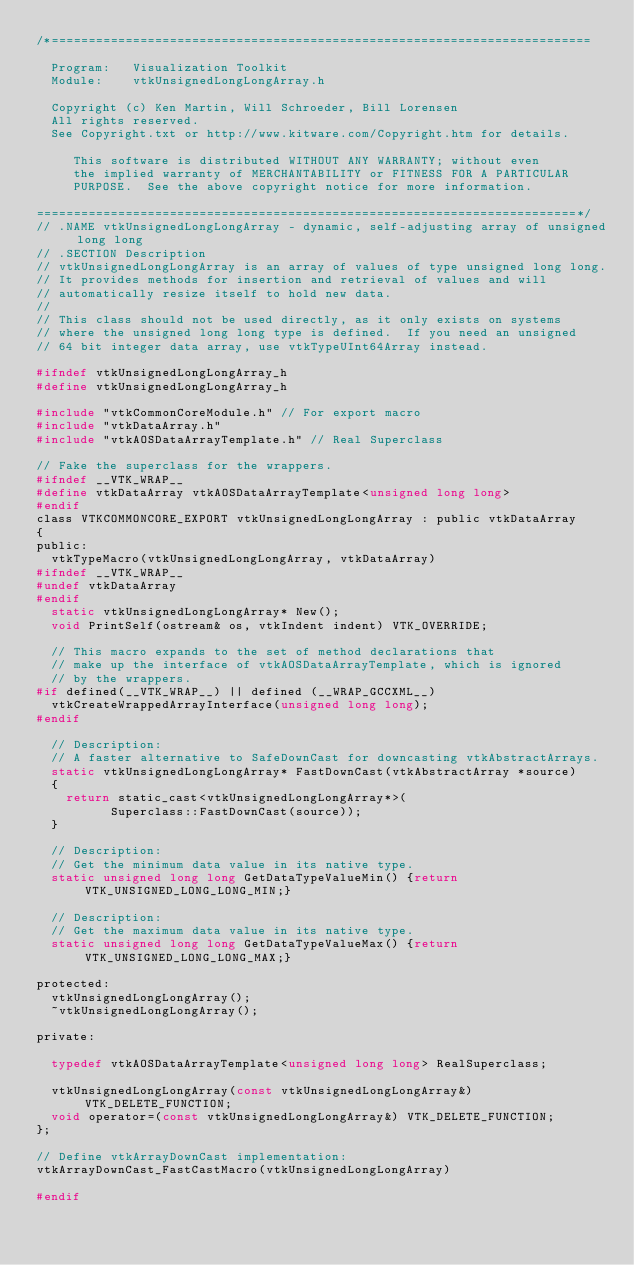Convert code to text. <code><loc_0><loc_0><loc_500><loc_500><_C_>/*=========================================================================

  Program:   Visualization Toolkit
  Module:    vtkUnsignedLongLongArray.h

  Copyright (c) Ken Martin, Will Schroeder, Bill Lorensen
  All rights reserved.
  See Copyright.txt or http://www.kitware.com/Copyright.htm for details.

     This software is distributed WITHOUT ANY WARRANTY; without even
     the implied warranty of MERCHANTABILITY or FITNESS FOR A PARTICULAR
     PURPOSE.  See the above copyright notice for more information.

=========================================================================*/
// .NAME vtkUnsignedLongLongArray - dynamic, self-adjusting array of unsigned long long
// .SECTION Description
// vtkUnsignedLongLongArray is an array of values of type unsigned long long.
// It provides methods for insertion and retrieval of values and will
// automatically resize itself to hold new data.
//
// This class should not be used directly, as it only exists on systems
// where the unsigned long long type is defined.  If you need an unsigned
// 64 bit integer data array, use vtkTypeUInt64Array instead.

#ifndef vtkUnsignedLongLongArray_h
#define vtkUnsignedLongLongArray_h

#include "vtkCommonCoreModule.h" // For export macro
#include "vtkDataArray.h"
#include "vtkAOSDataArrayTemplate.h" // Real Superclass

// Fake the superclass for the wrappers.
#ifndef __VTK_WRAP__
#define vtkDataArray vtkAOSDataArrayTemplate<unsigned long long>
#endif
class VTKCOMMONCORE_EXPORT vtkUnsignedLongLongArray : public vtkDataArray
{
public:
  vtkTypeMacro(vtkUnsignedLongLongArray, vtkDataArray)
#ifndef __VTK_WRAP__
#undef vtkDataArray
#endif
  static vtkUnsignedLongLongArray* New();
  void PrintSelf(ostream& os, vtkIndent indent) VTK_OVERRIDE;

  // This macro expands to the set of method declarations that
  // make up the interface of vtkAOSDataArrayTemplate, which is ignored
  // by the wrappers.
#if defined(__VTK_WRAP__) || defined (__WRAP_GCCXML__)
  vtkCreateWrappedArrayInterface(unsigned long long);
#endif

  // Description:
  // A faster alternative to SafeDownCast for downcasting vtkAbstractArrays.
  static vtkUnsignedLongLongArray* FastDownCast(vtkAbstractArray *source)
  {
    return static_cast<vtkUnsignedLongLongArray*>(
          Superclass::FastDownCast(source));
  }

  // Description:
  // Get the minimum data value in its native type.
  static unsigned long long GetDataTypeValueMin() {return VTK_UNSIGNED_LONG_LONG_MIN;}

  // Description:
  // Get the maximum data value in its native type.
  static unsigned long long GetDataTypeValueMax() {return VTK_UNSIGNED_LONG_LONG_MAX;}

protected:
  vtkUnsignedLongLongArray();
  ~vtkUnsignedLongLongArray();

private:

  typedef vtkAOSDataArrayTemplate<unsigned long long> RealSuperclass;

  vtkUnsignedLongLongArray(const vtkUnsignedLongLongArray&) VTK_DELETE_FUNCTION;
  void operator=(const vtkUnsignedLongLongArray&) VTK_DELETE_FUNCTION;
};

// Define vtkArrayDownCast implementation:
vtkArrayDownCast_FastCastMacro(vtkUnsignedLongLongArray)

#endif
</code> 